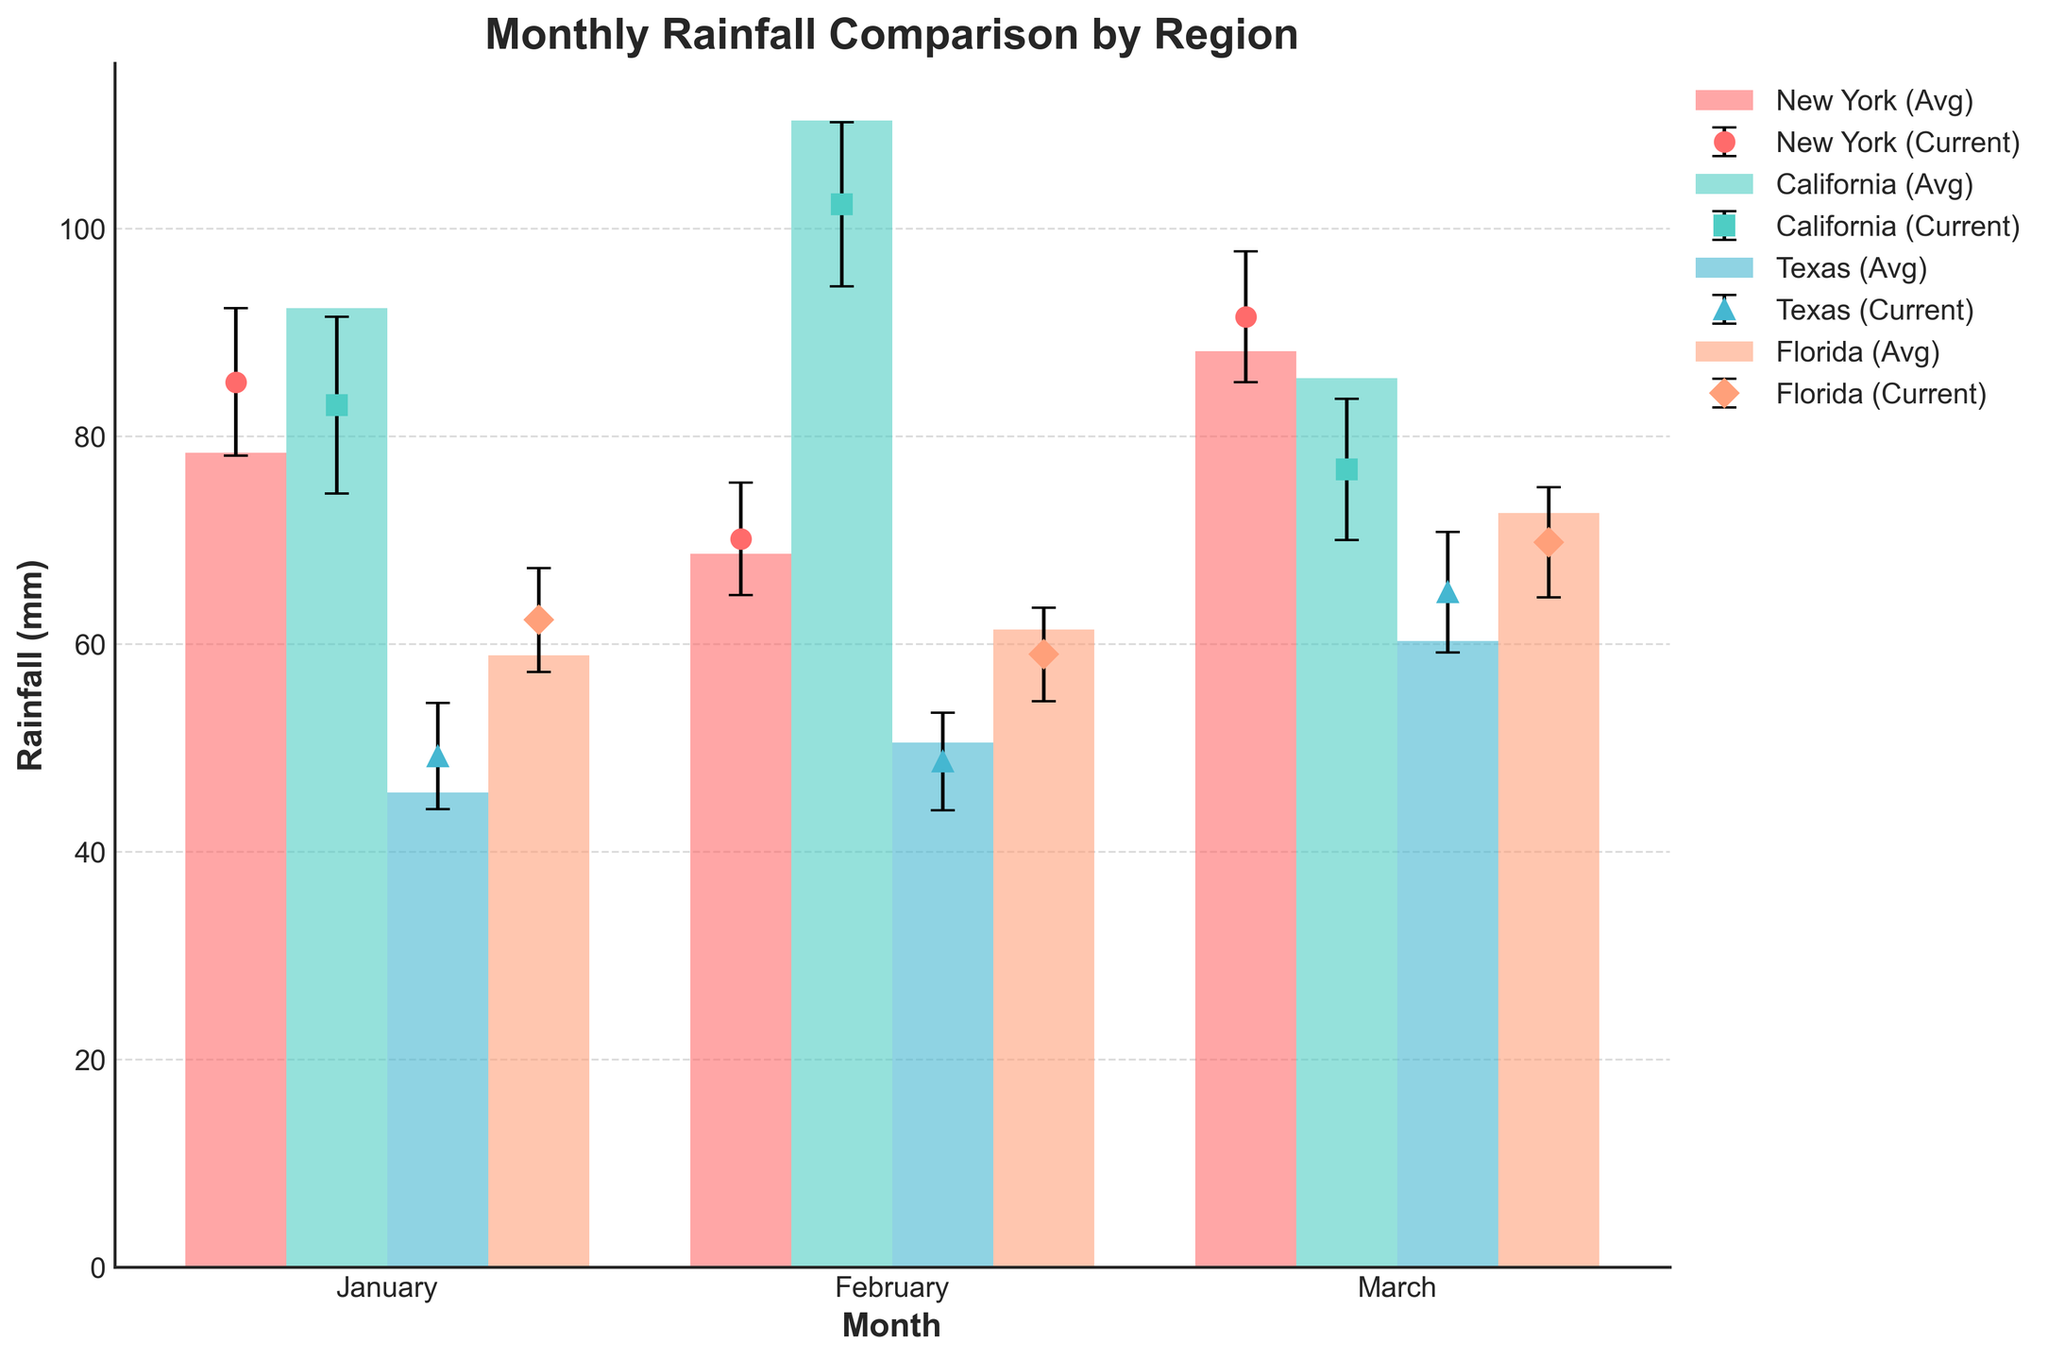What is the title of the figure? The title of the figure is displayed at the top and states "Monthly Rainfall Comparison by Region".
Answer: Monthly Rainfall Comparison by Region Which region has the highest average rainfall in January? By examining the bars for January, California has the highest average rainfall among the regions shown.
Answer: California What is the difference in current year rainfall between Texas and Florida in March? The current year rainfall for Texas in March is about 65.0 mm, while for Florida, it is about 69.8 mm. The difference is \(69.8 - 65.0\).
Answer: 4.8 mm How many months are compared in the figure? The x-axis shows the labels for each month under comparison. There are three distinct labels: January, February, and March.
Answer: 3 Which region has the smallest standard deviation in January? The error bars represent the standard deviation. Comparing the lengths, Florida has the smallest error bar in January.
Answer: Florida In which month does New York have the highest current year rainfall? Referring to the markers with error bars for New York, the highest marker is in March with around 91.5 mm.
Answer: March Compare the average rainfall and current year rainfall for California in February. How far apart are they? The average rainfall for California in February is around 110.4 mm, while the current year rainfall is about 102.3 mm. The difference is \(110.4 - 102.3\).
Answer: 8.1 mm Is the current year rainfall in New York above or below its historical average in February? The current year rainfall for New York in February is slightly above the historical average by looking at the marker being higher than the bar.
Answer: Above Which region shows the largest decrease from the historical average to the current year rainfall in January? By comparing the lengths of the bars and markers in January, California has the largest decrease from its historical average to the current year rainfall.
Answer: California What are the ranges of standard deviations for all regions in March? The error bars represent the standard deviations. For New York: 6.3 mm, California: 6.8 mm, Texas: 5.8 mm, Florida: 5.3 mm.
Answer: New York: 6.3 mm, California: 6.8 mm, Texas: 5.8 mm, Florida: 5.3 mm 